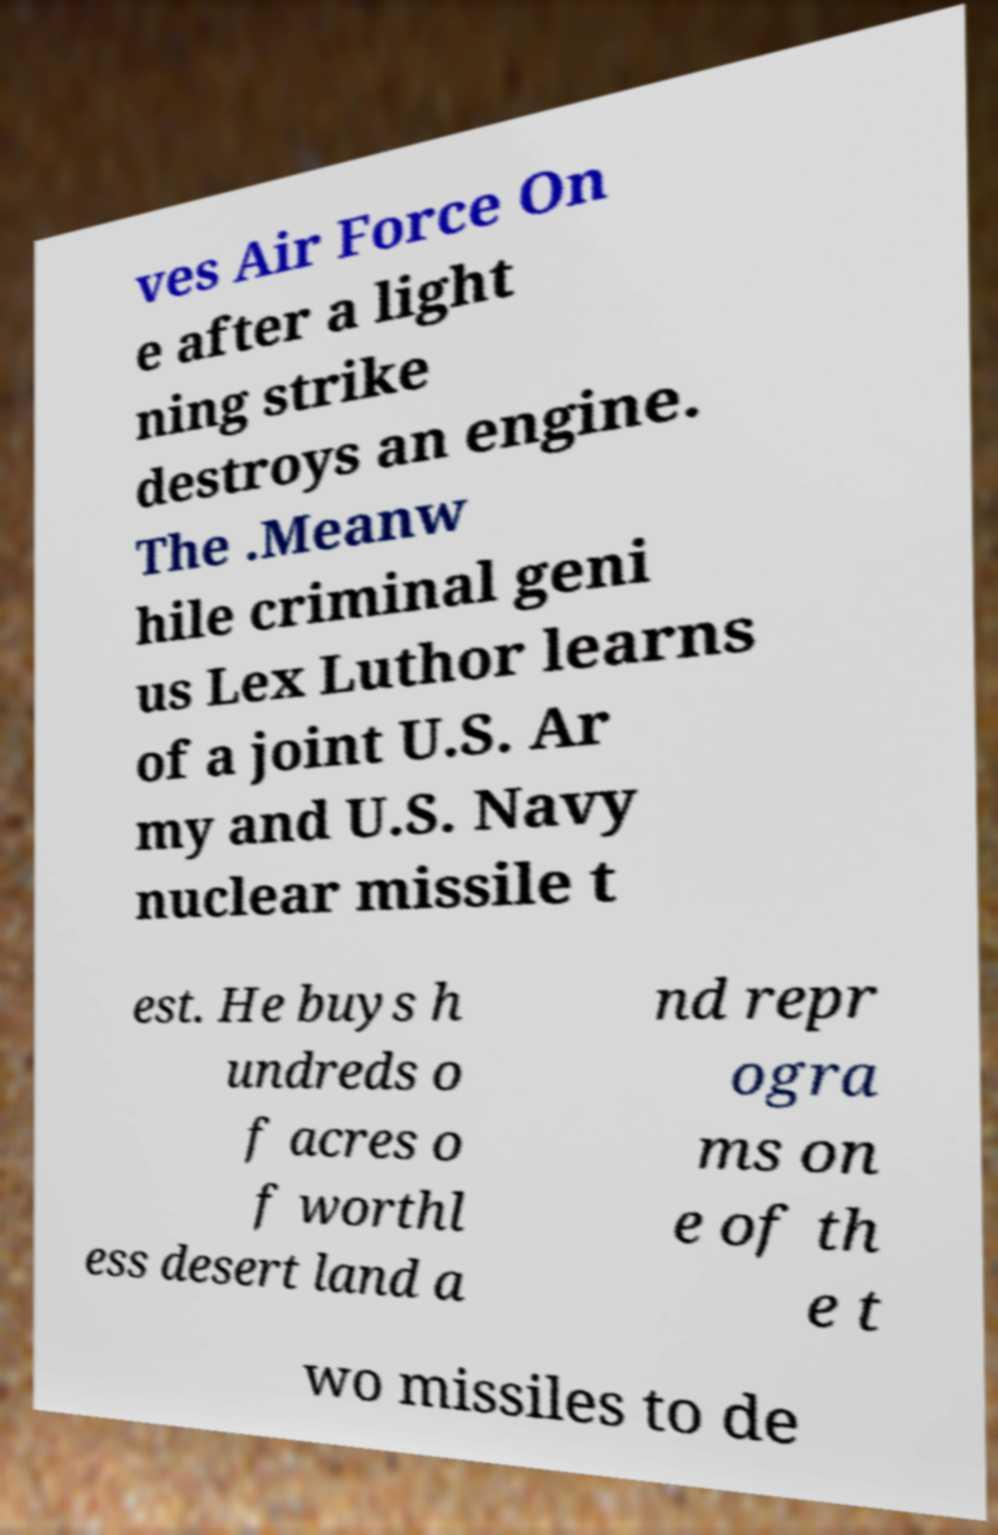I need the written content from this picture converted into text. Can you do that? ves Air Force On e after a light ning strike destroys an engine. The .Meanw hile criminal geni us Lex Luthor learns of a joint U.S. Ar my and U.S. Navy nuclear missile t est. He buys h undreds o f acres o f worthl ess desert land a nd repr ogra ms on e of th e t wo missiles to de 